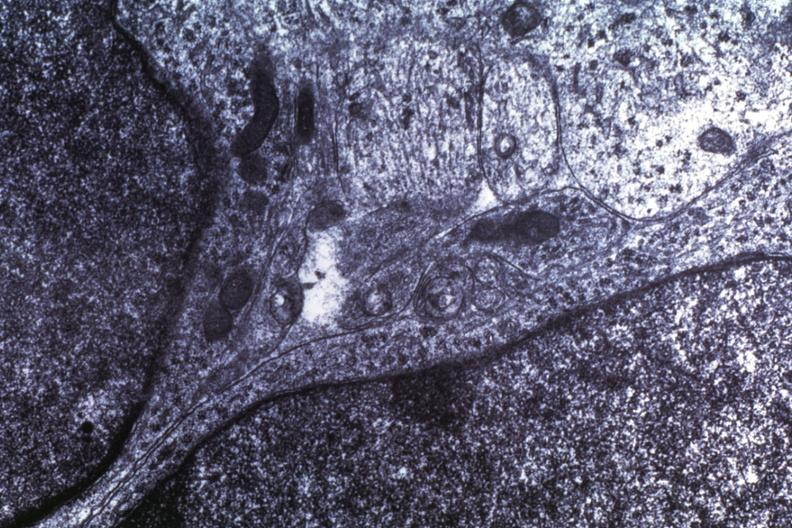s brain present?
Answer the question using a single word or phrase. No 